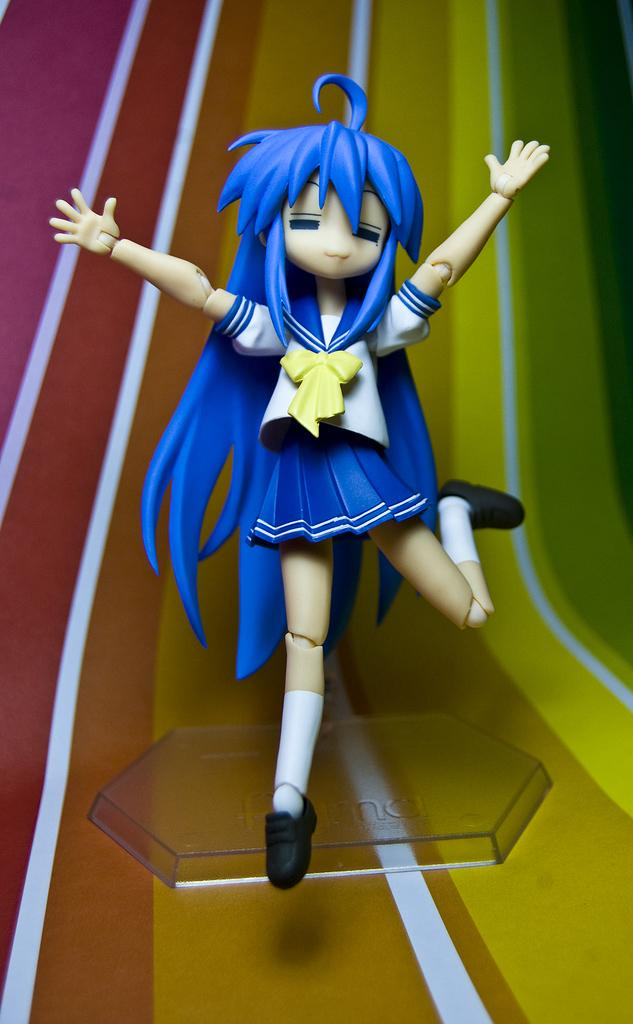What type of toy is in the image? There is a blue and white girl toy in the image. Can you describe the background of the image? The background of the image is colorful. What nation is represented by the girl toy in the image? The girl toy does not represent any specific nation; it is a toy. 